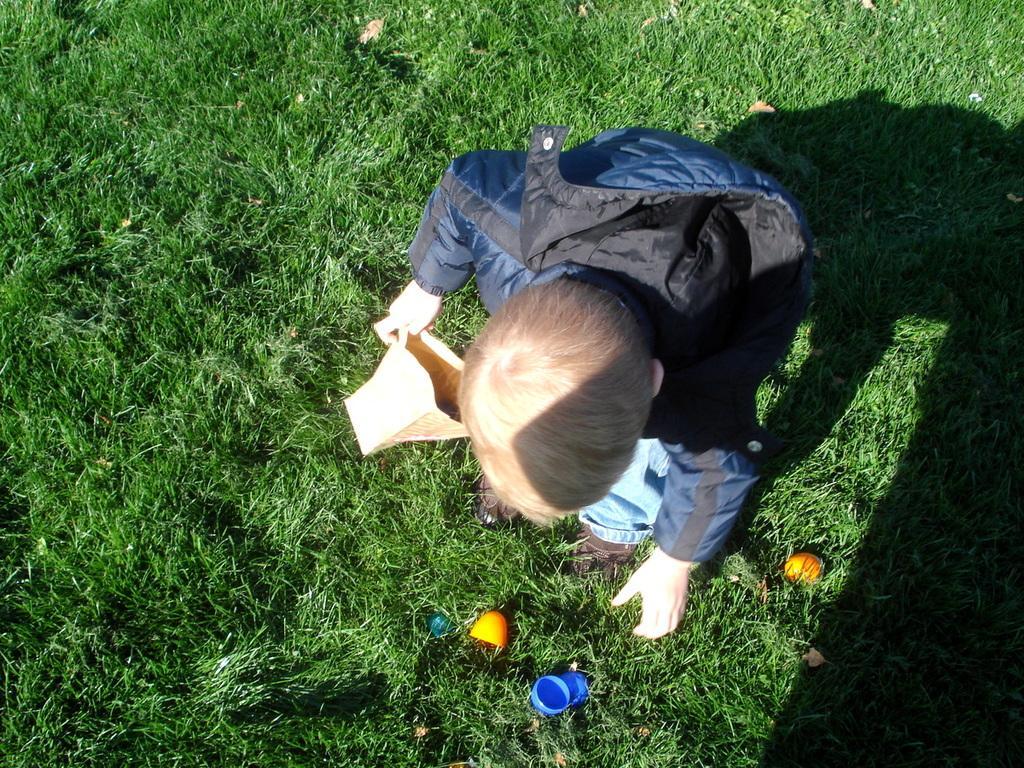How would you summarize this image in a sentence or two? In the center of the image there is a boy holding a paper basket in his hand and the background is full of grass. Image also consists of two orange color objects and a blue color object. 